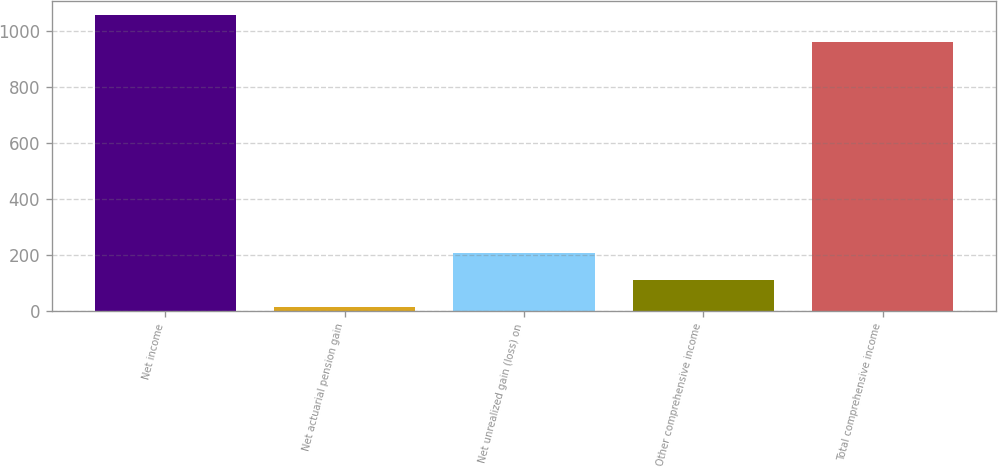Convert chart. <chart><loc_0><loc_0><loc_500><loc_500><bar_chart><fcel>Net income<fcel>Net actuarial pension gain<fcel>Net unrealized gain (loss) on<fcel>Other comprehensive income<fcel>Total comprehensive income<nl><fcel>1056.6<fcel>14<fcel>207.2<fcel>110.6<fcel>960<nl></chart> 